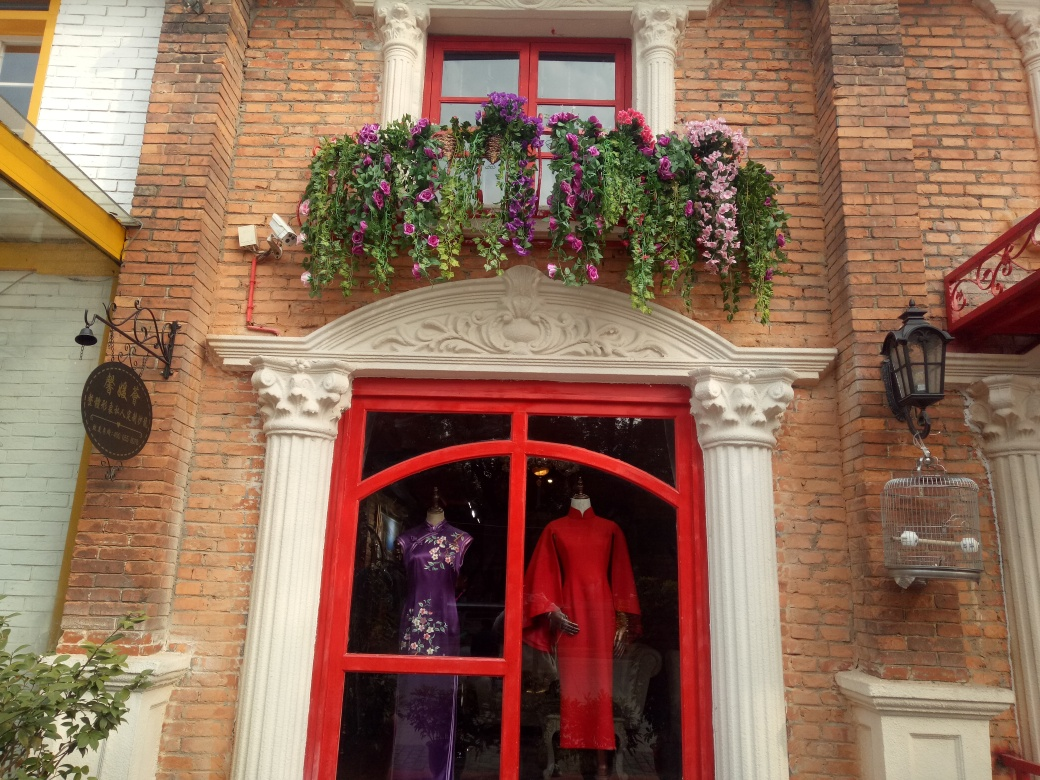How is the focus in this image? The focus in this image is clear, with the details of the brick texture, window frames, and the vibrant clothing on display in the shop's window being quite sharp. The flowers add a nice touch of softness and detail, contributing to the visual appeal of the scene. 